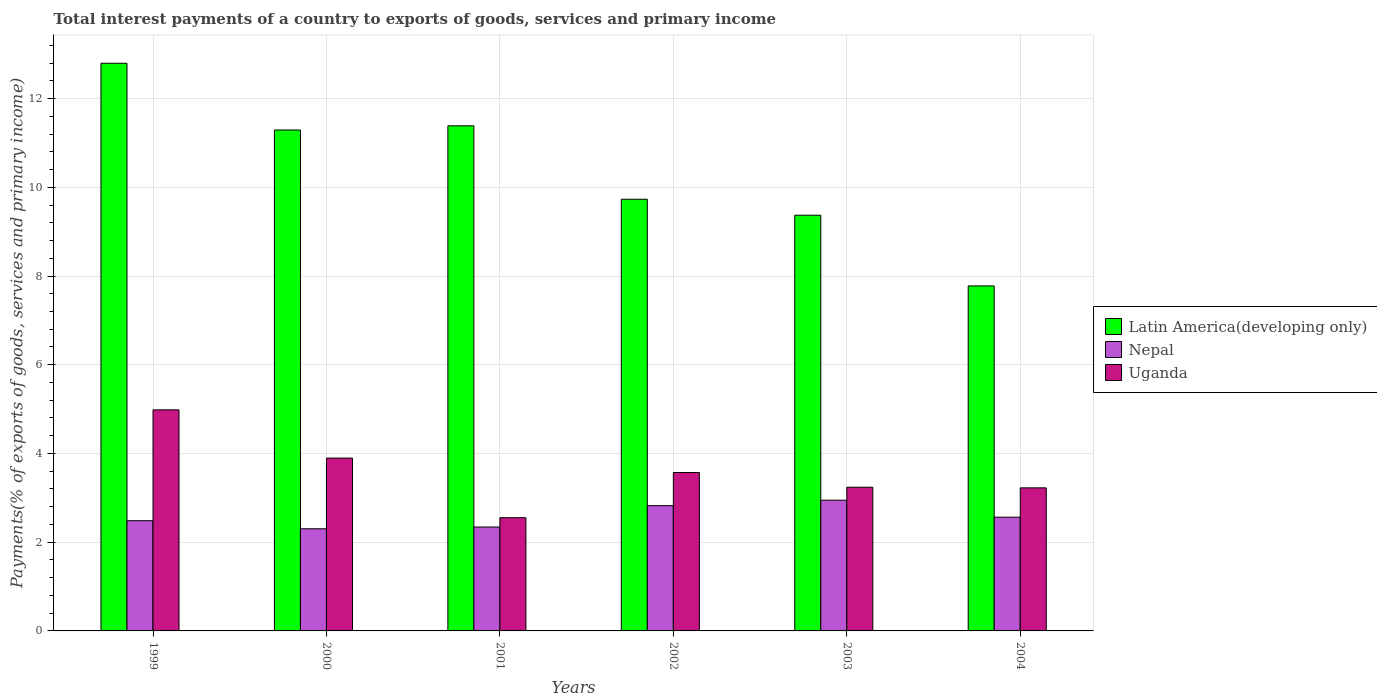How many groups of bars are there?
Your response must be concise. 6. Are the number of bars per tick equal to the number of legend labels?
Make the answer very short. Yes. How many bars are there on the 5th tick from the left?
Your answer should be compact. 3. What is the total interest payments in Latin America(developing only) in 1999?
Your answer should be very brief. 12.8. Across all years, what is the maximum total interest payments in Uganda?
Make the answer very short. 4.98. Across all years, what is the minimum total interest payments in Nepal?
Your answer should be compact. 2.3. In which year was the total interest payments in Nepal maximum?
Give a very brief answer. 2003. What is the total total interest payments in Uganda in the graph?
Offer a very short reply. 21.47. What is the difference between the total interest payments in Uganda in 1999 and that in 2000?
Provide a succinct answer. 1.09. What is the difference between the total interest payments in Nepal in 2000 and the total interest payments in Uganda in 2001?
Provide a short and direct response. -0.25. What is the average total interest payments in Latin America(developing only) per year?
Give a very brief answer. 10.39. In the year 2003, what is the difference between the total interest payments in Latin America(developing only) and total interest payments in Uganda?
Give a very brief answer. 6.13. In how many years, is the total interest payments in Uganda greater than 8.4 %?
Offer a terse response. 0. What is the ratio of the total interest payments in Latin America(developing only) in 1999 to that in 2003?
Make the answer very short. 1.37. Is the total interest payments in Latin America(developing only) in 2001 less than that in 2003?
Ensure brevity in your answer.  No. What is the difference between the highest and the second highest total interest payments in Latin America(developing only)?
Provide a succinct answer. 1.41. What is the difference between the highest and the lowest total interest payments in Nepal?
Your answer should be compact. 0.64. Is the sum of the total interest payments in Uganda in 2002 and 2004 greater than the maximum total interest payments in Nepal across all years?
Your answer should be very brief. Yes. What does the 3rd bar from the left in 2001 represents?
Provide a succinct answer. Uganda. What does the 1st bar from the right in 2002 represents?
Your answer should be compact. Uganda. Are all the bars in the graph horizontal?
Provide a succinct answer. No. What is the difference between two consecutive major ticks on the Y-axis?
Keep it short and to the point. 2. Does the graph contain any zero values?
Give a very brief answer. No. How many legend labels are there?
Your answer should be very brief. 3. What is the title of the graph?
Offer a very short reply. Total interest payments of a country to exports of goods, services and primary income. Does "Russian Federation" appear as one of the legend labels in the graph?
Offer a very short reply. No. What is the label or title of the Y-axis?
Provide a short and direct response. Payments(% of exports of goods, services and primary income). What is the Payments(% of exports of goods, services and primary income) of Latin America(developing only) in 1999?
Ensure brevity in your answer.  12.8. What is the Payments(% of exports of goods, services and primary income) in Nepal in 1999?
Provide a succinct answer. 2.48. What is the Payments(% of exports of goods, services and primary income) of Uganda in 1999?
Provide a succinct answer. 4.98. What is the Payments(% of exports of goods, services and primary income) in Latin America(developing only) in 2000?
Provide a succinct answer. 11.29. What is the Payments(% of exports of goods, services and primary income) of Nepal in 2000?
Give a very brief answer. 2.3. What is the Payments(% of exports of goods, services and primary income) of Uganda in 2000?
Offer a very short reply. 3.9. What is the Payments(% of exports of goods, services and primary income) of Latin America(developing only) in 2001?
Provide a succinct answer. 11.39. What is the Payments(% of exports of goods, services and primary income) in Nepal in 2001?
Provide a short and direct response. 2.34. What is the Payments(% of exports of goods, services and primary income) of Uganda in 2001?
Give a very brief answer. 2.55. What is the Payments(% of exports of goods, services and primary income) of Latin America(developing only) in 2002?
Keep it short and to the point. 9.73. What is the Payments(% of exports of goods, services and primary income) of Nepal in 2002?
Your answer should be compact. 2.82. What is the Payments(% of exports of goods, services and primary income) of Uganda in 2002?
Offer a very short reply. 3.57. What is the Payments(% of exports of goods, services and primary income) of Latin America(developing only) in 2003?
Offer a very short reply. 9.37. What is the Payments(% of exports of goods, services and primary income) of Nepal in 2003?
Provide a succinct answer. 2.95. What is the Payments(% of exports of goods, services and primary income) in Uganda in 2003?
Offer a terse response. 3.24. What is the Payments(% of exports of goods, services and primary income) of Latin America(developing only) in 2004?
Provide a short and direct response. 7.78. What is the Payments(% of exports of goods, services and primary income) of Nepal in 2004?
Offer a terse response. 2.56. What is the Payments(% of exports of goods, services and primary income) in Uganda in 2004?
Offer a very short reply. 3.22. Across all years, what is the maximum Payments(% of exports of goods, services and primary income) in Latin America(developing only)?
Your response must be concise. 12.8. Across all years, what is the maximum Payments(% of exports of goods, services and primary income) of Nepal?
Your answer should be compact. 2.95. Across all years, what is the maximum Payments(% of exports of goods, services and primary income) of Uganda?
Your answer should be very brief. 4.98. Across all years, what is the minimum Payments(% of exports of goods, services and primary income) of Latin America(developing only)?
Give a very brief answer. 7.78. Across all years, what is the minimum Payments(% of exports of goods, services and primary income) in Nepal?
Give a very brief answer. 2.3. Across all years, what is the minimum Payments(% of exports of goods, services and primary income) of Uganda?
Your response must be concise. 2.55. What is the total Payments(% of exports of goods, services and primary income) of Latin America(developing only) in the graph?
Offer a terse response. 62.35. What is the total Payments(% of exports of goods, services and primary income) in Nepal in the graph?
Your answer should be compact. 15.46. What is the total Payments(% of exports of goods, services and primary income) in Uganda in the graph?
Provide a succinct answer. 21.47. What is the difference between the Payments(% of exports of goods, services and primary income) of Latin America(developing only) in 1999 and that in 2000?
Your response must be concise. 1.5. What is the difference between the Payments(% of exports of goods, services and primary income) in Nepal in 1999 and that in 2000?
Ensure brevity in your answer.  0.18. What is the difference between the Payments(% of exports of goods, services and primary income) of Uganda in 1999 and that in 2000?
Your answer should be compact. 1.09. What is the difference between the Payments(% of exports of goods, services and primary income) in Latin America(developing only) in 1999 and that in 2001?
Your answer should be very brief. 1.41. What is the difference between the Payments(% of exports of goods, services and primary income) in Nepal in 1999 and that in 2001?
Ensure brevity in your answer.  0.14. What is the difference between the Payments(% of exports of goods, services and primary income) in Uganda in 1999 and that in 2001?
Provide a succinct answer. 2.43. What is the difference between the Payments(% of exports of goods, services and primary income) of Latin America(developing only) in 1999 and that in 2002?
Keep it short and to the point. 3.07. What is the difference between the Payments(% of exports of goods, services and primary income) of Nepal in 1999 and that in 2002?
Offer a terse response. -0.34. What is the difference between the Payments(% of exports of goods, services and primary income) in Uganda in 1999 and that in 2002?
Make the answer very short. 1.41. What is the difference between the Payments(% of exports of goods, services and primary income) in Latin America(developing only) in 1999 and that in 2003?
Your answer should be compact. 3.43. What is the difference between the Payments(% of exports of goods, services and primary income) of Nepal in 1999 and that in 2003?
Give a very brief answer. -0.46. What is the difference between the Payments(% of exports of goods, services and primary income) of Uganda in 1999 and that in 2003?
Make the answer very short. 1.74. What is the difference between the Payments(% of exports of goods, services and primary income) of Latin America(developing only) in 1999 and that in 2004?
Your response must be concise. 5.02. What is the difference between the Payments(% of exports of goods, services and primary income) of Nepal in 1999 and that in 2004?
Your answer should be compact. -0.08. What is the difference between the Payments(% of exports of goods, services and primary income) in Uganda in 1999 and that in 2004?
Provide a succinct answer. 1.76. What is the difference between the Payments(% of exports of goods, services and primary income) in Latin America(developing only) in 2000 and that in 2001?
Offer a very short reply. -0.09. What is the difference between the Payments(% of exports of goods, services and primary income) of Nepal in 2000 and that in 2001?
Offer a very short reply. -0.04. What is the difference between the Payments(% of exports of goods, services and primary income) of Uganda in 2000 and that in 2001?
Make the answer very short. 1.34. What is the difference between the Payments(% of exports of goods, services and primary income) of Latin America(developing only) in 2000 and that in 2002?
Make the answer very short. 1.56. What is the difference between the Payments(% of exports of goods, services and primary income) in Nepal in 2000 and that in 2002?
Offer a very short reply. -0.52. What is the difference between the Payments(% of exports of goods, services and primary income) in Uganda in 2000 and that in 2002?
Your response must be concise. 0.33. What is the difference between the Payments(% of exports of goods, services and primary income) of Latin America(developing only) in 2000 and that in 2003?
Make the answer very short. 1.92. What is the difference between the Payments(% of exports of goods, services and primary income) of Nepal in 2000 and that in 2003?
Offer a very short reply. -0.64. What is the difference between the Payments(% of exports of goods, services and primary income) in Uganda in 2000 and that in 2003?
Keep it short and to the point. 0.66. What is the difference between the Payments(% of exports of goods, services and primary income) in Latin America(developing only) in 2000 and that in 2004?
Offer a very short reply. 3.51. What is the difference between the Payments(% of exports of goods, services and primary income) in Nepal in 2000 and that in 2004?
Offer a very short reply. -0.26. What is the difference between the Payments(% of exports of goods, services and primary income) in Uganda in 2000 and that in 2004?
Your answer should be very brief. 0.67. What is the difference between the Payments(% of exports of goods, services and primary income) of Latin America(developing only) in 2001 and that in 2002?
Offer a very short reply. 1.66. What is the difference between the Payments(% of exports of goods, services and primary income) of Nepal in 2001 and that in 2002?
Give a very brief answer. -0.48. What is the difference between the Payments(% of exports of goods, services and primary income) of Uganda in 2001 and that in 2002?
Your answer should be compact. -1.02. What is the difference between the Payments(% of exports of goods, services and primary income) in Latin America(developing only) in 2001 and that in 2003?
Your response must be concise. 2.02. What is the difference between the Payments(% of exports of goods, services and primary income) of Nepal in 2001 and that in 2003?
Offer a terse response. -0.6. What is the difference between the Payments(% of exports of goods, services and primary income) of Uganda in 2001 and that in 2003?
Your answer should be compact. -0.69. What is the difference between the Payments(% of exports of goods, services and primary income) in Latin America(developing only) in 2001 and that in 2004?
Keep it short and to the point. 3.61. What is the difference between the Payments(% of exports of goods, services and primary income) in Nepal in 2001 and that in 2004?
Give a very brief answer. -0.22. What is the difference between the Payments(% of exports of goods, services and primary income) of Uganda in 2001 and that in 2004?
Offer a terse response. -0.67. What is the difference between the Payments(% of exports of goods, services and primary income) in Latin America(developing only) in 2002 and that in 2003?
Offer a terse response. 0.36. What is the difference between the Payments(% of exports of goods, services and primary income) in Nepal in 2002 and that in 2003?
Ensure brevity in your answer.  -0.12. What is the difference between the Payments(% of exports of goods, services and primary income) of Uganda in 2002 and that in 2003?
Your response must be concise. 0.33. What is the difference between the Payments(% of exports of goods, services and primary income) of Latin America(developing only) in 2002 and that in 2004?
Your answer should be compact. 1.95. What is the difference between the Payments(% of exports of goods, services and primary income) in Nepal in 2002 and that in 2004?
Make the answer very short. 0.26. What is the difference between the Payments(% of exports of goods, services and primary income) of Uganda in 2002 and that in 2004?
Ensure brevity in your answer.  0.35. What is the difference between the Payments(% of exports of goods, services and primary income) in Latin America(developing only) in 2003 and that in 2004?
Make the answer very short. 1.59. What is the difference between the Payments(% of exports of goods, services and primary income) in Nepal in 2003 and that in 2004?
Offer a terse response. 0.38. What is the difference between the Payments(% of exports of goods, services and primary income) of Uganda in 2003 and that in 2004?
Your response must be concise. 0.01. What is the difference between the Payments(% of exports of goods, services and primary income) of Latin America(developing only) in 1999 and the Payments(% of exports of goods, services and primary income) of Nepal in 2000?
Make the answer very short. 10.49. What is the difference between the Payments(% of exports of goods, services and primary income) in Latin America(developing only) in 1999 and the Payments(% of exports of goods, services and primary income) in Uganda in 2000?
Provide a succinct answer. 8.9. What is the difference between the Payments(% of exports of goods, services and primary income) of Nepal in 1999 and the Payments(% of exports of goods, services and primary income) of Uganda in 2000?
Keep it short and to the point. -1.41. What is the difference between the Payments(% of exports of goods, services and primary income) of Latin America(developing only) in 1999 and the Payments(% of exports of goods, services and primary income) of Nepal in 2001?
Give a very brief answer. 10.45. What is the difference between the Payments(% of exports of goods, services and primary income) in Latin America(developing only) in 1999 and the Payments(% of exports of goods, services and primary income) in Uganda in 2001?
Your answer should be compact. 10.24. What is the difference between the Payments(% of exports of goods, services and primary income) of Nepal in 1999 and the Payments(% of exports of goods, services and primary income) of Uganda in 2001?
Offer a very short reply. -0.07. What is the difference between the Payments(% of exports of goods, services and primary income) in Latin America(developing only) in 1999 and the Payments(% of exports of goods, services and primary income) in Nepal in 2002?
Make the answer very short. 9.97. What is the difference between the Payments(% of exports of goods, services and primary income) of Latin America(developing only) in 1999 and the Payments(% of exports of goods, services and primary income) of Uganda in 2002?
Give a very brief answer. 9.22. What is the difference between the Payments(% of exports of goods, services and primary income) in Nepal in 1999 and the Payments(% of exports of goods, services and primary income) in Uganda in 2002?
Ensure brevity in your answer.  -1.09. What is the difference between the Payments(% of exports of goods, services and primary income) in Latin America(developing only) in 1999 and the Payments(% of exports of goods, services and primary income) in Nepal in 2003?
Provide a succinct answer. 9.85. What is the difference between the Payments(% of exports of goods, services and primary income) in Latin America(developing only) in 1999 and the Payments(% of exports of goods, services and primary income) in Uganda in 2003?
Provide a short and direct response. 9.56. What is the difference between the Payments(% of exports of goods, services and primary income) of Nepal in 1999 and the Payments(% of exports of goods, services and primary income) of Uganda in 2003?
Ensure brevity in your answer.  -0.75. What is the difference between the Payments(% of exports of goods, services and primary income) of Latin America(developing only) in 1999 and the Payments(% of exports of goods, services and primary income) of Nepal in 2004?
Ensure brevity in your answer.  10.23. What is the difference between the Payments(% of exports of goods, services and primary income) of Latin America(developing only) in 1999 and the Payments(% of exports of goods, services and primary income) of Uganda in 2004?
Your response must be concise. 9.57. What is the difference between the Payments(% of exports of goods, services and primary income) of Nepal in 1999 and the Payments(% of exports of goods, services and primary income) of Uganda in 2004?
Make the answer very short. -0.74. What is the difference between the Payments(% of exports of goods, services and primary income) in Latin America(developing only) in 2000 and the Payments(% of exports of goods, services and primary income) in Nepal in 2001?
Ensure brevity in your answer.  8.95. What is the difference between the Payments(% of exports of goods, services and primary income) in Latin America(developing only) in 2000 and the Payments(% of exports of goods, services and primary income) in Uganda in 2001?
Your answer should be very brief. 8.74. What is the difference between the Payments(% of exports of goods, services and primary income) of Nepal in 2000 and the Payments(% of exports of goods, services and primary income) of Uganda in 2001?
Provide a short and direct response. -0.25. What is the difference between the Payments(% of exports of goods, services and primary income) in Latin America(developing only) in 2000 and the Payments(% of exports of goods, services and primary income) in Nepal in 2002?
Offer a very short reply. 8.47. What is the difference between the Payments(% of exports of goods, services and primary income) of Latin America(developing only) in 2000 and the Payments(% of exports of goods, services and primary income) of Uganda in 2002?
Your answer should be very brief. 7.72. What is the difference between the Payments(% of exports of goods, services and primary income) in Nepal in 2000 and the Payments(% of exports of goods, services and primary income) in Uganda in 2002?
Provide a short and direct response. -1.27. What is the difference between the Payments(% of exports of goods, services and primary income) of Latin America(developing only) in 2000 and the Payments(% of exports of goods, services and primary income) of Nepal in 2003?
Keep it short and to the point. 8.34. What is the difference between the Payments(% of exports of goods, services and primary income) of Latin America(developing only) in 2000 and the Payments(% of exports of goods, services and primary income) of Uganda in 2003?
Offer a terse response. 8.05. What is the difference between the Payments(% of exports of goods, services and primary income) in Nepal in 2000 and the Payments(% of exports of goods, services and primary income) in Uganda in 2003?
Your answer should be very brief. -0.94. What is the difference between the Payments(% of exports of goods, services and primary income) of Latin America(developing only) in 2000 and the Payments(% of exports of goods, services and primary income) of Nepal in 2004?
Offer a very short reply. 8.73. What is the difference between the Payments(% of exports of goods, services and primary income) in Latin America(developing only) in 2000 and the Payments(% of exports of goods, services and primary income) in Uganda in 2004?
Make the answer very short. 8.07. What is the difference between the Payments(% of exports of goods, services and primary income) in Nepal in 2000 and the Payments(% of exports of goods, services and primary income) in Uganda in 2004?
Provide a short and direct response. -0.92. What is the difference between the Payments(% of exports of goods, services and primary income) of Latin America(developing only) in 2001 and the Payments(% of exports of goods, services and primary income) of Nepal in 2002?
Your response must be concise. 8.56. What is the difference between the Payments(% of exports of goods, services and primary income) of Latin America(developing only) in 2001 and the Payments(% of exports of goods, services and primary income) of Uganda in 2002?
Ensure brevity in your answer.  7.81. What is the difference between the Payments(% of exports of goods, services and primary income) of Nepal in 2001 and the Payments(% of exports of goods, services and primary income) of Uganda in 2002?
Provide a short and direct response. -1.23. What is the difference between the Payments(% of exports of goods, services and primary income) in Latin America(developing only) in 2001 and the Payments(% of exports of goods, services and primary income) in Nepal in 2003?
Ensure brevity in your answer.  8.44. What is the difference between the Payments(% of exports of goods, services and primary income) in Latin America(developing only) in 2001 and the Payments(% of exports of goods, services and primary income) in Uganda in 2003?
Make the answer very short. 8.15. What is the difference between the Payments(% of exports of goods, services and primary income) in Nepal in 2001 and the Payments(% of exports of goods, services and primary income) in Uganda in 2003?
Your answer should be compact. -0.9. What is the difference between the Payments(% of exports of goods, services and primary income) of Latin America(developing only) in 2001 and the Payments(% of exports of goods, services and primary income) of Nepal in 2004?
Ensure brevity in your answer.  8.82. What is the difference between the Payments(% of exports of goods, services and primary income) of Latin America(developing only) in 2001 and the Payments(% of exports of goods, services and primary income) of Uganda in 2004?
Ensure brevity in your answer.  8.16. What is the difference between the Payments(% of exports of goods, services and primary income) in Nepal in 2001 and the Payments(% of exports of goods, services and primary income) in Uganda in 2004?
Your response must be concise. -0.88. What is the difference between the Payments(% of exports of goods, services and primary income) of Latin America(developing only) in 2002 and the Payments(% of exports of goods, services and primary income) of Nepal in 2003?
Ensure brevity in your answer.  6.78. What is the difference between the Payments(% of exports of goods, services and primary income) of Latin America(developing only) in 2002 and the Payments(% of exports of goods, services and primary income) of Uganda in 2003?
Provide a succinct answer. 6.49. What is the difference between the Payments(% of exports of goods, services and primary income) of Nepal in 2002 and the Payments(% of exports of goods, services and primary income) of Uganda in 2003?
Keep it short and to the point. -0.42. What is the difference between the Payments(% of exports of goods, services and primary income) in Latin America(developing only) in 2002 and the Payments(% of exports of goods, services and primary income) in Nepal in 2004?
Provide a short and direct response. 7.17. What is the difference between the Payments(% of exports of goods, services and primary income) of Latin America(developing only) in 2002 and the Payments(% of exports of goods, services and primary income) of Uganda in 2004?
Provide a succinct answer. 6.51. What is the difference between the Payments(% of exports of goods, services and primary income) in Nepal in 2002 and the Payments(% of exports of goods, services and primary income) in Uganda in 2004?
Provide a short and direct response. -0.4. What is the difference between the Payments(% of exports of goods, services and primary income) of Latin America(developing only) in 2003 and the Payments(% of exports of goods, services and primary income) of Nepal in 2004?
Offer a very short reply. 6.81. What is the difference between the Payments(% of exports of goods, services and primary income) of Latin America(developing only) in 2003 and the Payments(% of exports of goods, services and primary income) of Uganda in 2004?
Offer a terse response. 6.14. What is the difference between the Payments(% of exports of goods, services and primary income) in Nepal in 2003 and the Payments(% of exports of goods, services and primary income) in Uganda in 2004?
Offer a very short reply. -0.28. What is the average Payments(% of exports of goods, services and primary income) of Latin America(developing only) per year?
Provide a succinct answer. 10.39. What is the average Payments(% of exports of goods, services and primary income) of Nepal per year?
Make the answer very short. 2.58. What is the average Payments(% of exports of goods, services and primary income) of Uganda per year?
Provide a succinct answer. 3.58. In the year 1999, what is the difference between the Payments(% of exports of goods, services and primary income) of Latin America(developing only) and Payments(% of exports of goods, services and primary income) of Nepal?
Make the answer very short. 10.31. In the year 1999, what is the difference between the Payments(% of exports of goods, services and primary income) in Latin America(developing only) and Payments(% of exports of goods, services and primary income) in Uganda?
Your answer should be very brief. 7.81. In the year 1999, what is the difference between the Payments(% of exports of goods, services and primary income) of Nepal and Payments(% of exports of goods, services and primary income) of Uganda?
Your answer should be compact. -2.5. In the year 2000, what is the difference between the Payments(% of exports of goods, services and primary income) in Latin America(developing only) and Payments(% of exports of goods, services and primary income) in Nepal?
Your answer should be compact. 8.99. In the year 2000, what is the difference between the Payments(% of exports of goods, services and primary income) in Latin America(developing only) and Payments(% of exports of goods, services and primary income) in Uganda?
Offer a very short reply. 7.4. In the year 2000, what is the difference between the Payments(% of exports of goods, services and primary income) in Nepal and Payments(% of exports of goods, services and primary income) in Uganda?
Your response must be concise. -1.59. In the year 2001, what is the difference between the Payments(% of exports of goods, services and primary income) in Latin America(developing only) and Payments(% of exports of goods, services and primary income) in Nepal?
Give a very brief answer. 9.04. In the year 2001, what is the difference between the Payments(% of exports of goods, services and primary income) in Latin America(developing only) and Payments(% of exports of goods, services and primary income) in Uganda?
Your response must be concise. 8.83. In the year 2001, what is the difference between the Payments(% of exports of goods, services and primary income) in Nepal and Payments(% of exports of goods, services and primary income) in Uganda?
Your answer should be compact. -0.21. In the year 2002, what is the difference between the Payments(% of exports of goods, services and primary income) in Latin America(developing only) and Payments(% of exports of goods, services and primary income) in Nepal?
Offer a very short reply. 6.91. In the year 2002, what is the difference between the Payments(% of exports of goods, services and primary income) in Latin America(developing only) and Payments(% of exports of goods, services and primary income) in Uganda?
Give a very brief answer. 6.16. In the year 2002, what is the difference between the Payments(% of exports of goods, services and primary income) in Nepal and Payments(% of exports of goods, services and primary income) in Uganda?
Your response must be concise. -0.75. In the year 2003, what is the difference between the Payments(% of exports of goods, services and primary income) of Latin America(developing only) and Payments(% of exports of goods, services and primary income) of Nepal?
Your response must be concise. 6.42. In the year 2003, what is the difference between the Payments(% of exports of goods, services and primary income) in Latin America(developing only) and Payments(% of exports of goods, services and primary income) in Uganda?
Offer a terse response. 6.13. In the year 2003, what is the difference between the Payments(% of exports of goods, services and primary income) in Nepal and Payments(% of exports of goods, services and primary income) in Uganda?
Make the answer very short. -0.29. In the year 2004, what is the difference between the Payments(% of exports of goods, services and primary income) in Latin America(developing only) and Payments(% of exports of goods, services and primary income) in Nepal?
Your answer should be very brief. 5.21. In the year 2004, what is the difference between the Payments(% of exports of goods, services and primary income) in Latin America(developing only) and Payments(% of exports of goods, services and primary income) in Uganda?
Provide a short and direct response. 4.55. In the year 2004, what is the difference between the Payments(% of exports of goods, services and primary income) in Nepal and Payments(% of exports of goods, services and primary income) in Uganda?
Your answer should be very brief. -0.66. What is the ratio of the Payments(% of exports of goods, services and primary income) in Latin America(developing only) in 1999 to that in 2000?
Ensure brevity in your answer.  1.13. What is the ratio of the Payments(% of exports of goods, services and primary income) in Nepal in 1999 to that in 2000?
Provide a short and direct response. 1.08. What is the ratio of the Payments(% of exports of goods, services and primary income) in Uganda in 1999 to that in 2000?
Keep it short and to the point. 1.28. What is the ratio of the Payments(% of exports of goods, services and primary income) in Latin America(developing only) in 1999 to that in 2001?
Offer a very short reply. 1.12. What is the ratio of the Payments(% of exports of goods, services and primary income) in Nepal in 1999 to that in 2001?
Make the answer very short. 1.06. What is the ratio of the Payments(% of exports of goods, services and primary income) in Uganda in 1999 to that in 2001?
Ensure brevity in your answer.  1.95. What is the ratio of the Payments(% of exports of goods, services and primary income) of Latin America(developing only) in 1999 to that in 2002?
Your answer should be very brief. 1.31. What is the ratio of the Payments(% of exports of goods, services and primary income) of Nepal in 1999 to that in 2002?
Offer a terse response. 0.88. What is the ratio of the Payments(% of exports of goods, services and primary income) of Uganda in 1999 to that in 2002?
Keep it short and to the point. 1.4. What is the ratio of the Payments(% of exports of goods, services and primary income) in Latin America(developing only) in 1999 to that in 2003?
Ensure brevity in your answer.  1.37. What is the ratio of the Payments(% of exports of goods, services and primary income) in Nepal in 1999 to that in 2003?
Keep it short and to the point. 0.84. What is the ratio of the Payments(% of exports of goods, services and primary income) of Uganda in 1999 to that in 2003?
Ensure brevity in your answer.  1.54. What is the ratio of the Payments(% of exports of goods, services and primary income) of Latin America(developing only) in 1999 to that in 2004?
Offer a very short reply. 1.65. What is the ratio of the Payments(% of exports of goods, services and primary income) of Nepal in 1999 to that in 2004?
Make the answer very short. 0.97. What is the ratio of the Payments(% of exports of goods, services and primary income) of Uganda in 1999 to that in 2004?
Provide a short and direct response. 1.55. What is the ratio of the Payments(% of exports of goods, services and primary income) of Latin America(developing only) in 2000 to that in 2001?
Provide a succinct answer. 0.99. What is the ratio of the Payments(% of exports of goods, services and primary income) in Nepal in 2000 to that in 2001?
Provide a short and direct response. 0.98. What is the ratio of the Payments(% of exports of goods, services and primary income) of Uganda in 2000 to that in 2001?
Ensure brevity in your answer.  1.53. What is the ratio of the Payments(% of exports of goods, services and primary income) in Latin America(developing only) in 2000 to that in 2002?
Offer a terse response. 1.16. What is the ratio of the Payments(% of exports of goods, services and primary income) of Nepal in 2000 to that in 2002?
Make the answer very short. 0.82. What is the ratio of the Payments(% of exports of goods, services and primary income) of Uganda in 2000 to that in 2002?
Your answer should be very brief. 1.09. What is the ratio of the Payments(% of exports of goods, services and primary income) in Latin America(developing only) in 2000 to that in 2003?
Your answer should be compact. 1.21. What is the ratio of the Payments(% of exports of goods, services and primary income) of Nepal in 2000 to that in 2003?
Give a very brief answer. 0.78. What is the ratio of the Payments(% of exports of goods, services and primary income) in Uganda in 2000 to that in 2003?
Ensure brevity in your answer.  1.2. What is the ratio of the Payments(% of exports of goods, services and primary income) in Latin America(developing only) in 2000 to that in 2004?
Make the answer very short. 1.45. What is the ratio of the Payments(% of exports of goods, services and primary income) of Nepal in 2000 to that in 2004?
Your answer should be compact. 0.9. What is the ratio of the Payments(% of exports of goods, services and primary income) of Uganda in 2000 to that in 2004?
Make the answer very short. 1.21. What is the ratio of the Payments(% of exports of goods, services and primary income) of Latin America(developing only) in 2001 to that in 2002?
Your response must be concise. 1.17. What is the ratio of the Payments(% of exports of goods, services and primary income) of Nepal in 2001 to that in 2002?
Keep it short and to the point. 0.83. What is the ratio of the Payments(% of exports of goods, services and primary income) of Uganda in 2001 to that in 2002?
Provide a short and direct response. 0.71. What is the ratio of the Payments(% of exports of goods, services and primary income) in Latin America(developing only) in 2001 to that in 2003?
Provide a short and direct response. 1.22. What is the ratio of the Payments(% of exports of goods, services and primary income) in Nepal in 2001 to that in 2003?
Your response must be concise. 0.79. What is the ratio of the Payments(% of exports of goods, services and primary income) in Uganda in 2001 to that in 2003?
Give a very brief answer. 0.79. What is the ratio of the Payments(% of exports of goods, services and primary income) in Latin America(developing only) in 2001 to that in 2004?
Provide a succinct answer. 1.46. What is the ratio of the Payments(% of exports of goods, services and primary income) in Nepal in 2001 to that in 2004?
Give a very brief answer. 0.91. What is the ratio of the Payments(% of exports of goods, services and primary income) in Uganda in 2001 to that in 2004?
Give a very brief answer. 0.79. What is the ratio of the Payments(% of exports of goods, services and primary income) in Nepal in 2002 to that in 2003?
Offer a terse response. 0.96. What is the ratio of the Payments(% of exports of goods, services and primary income) in Uganda in 2002 to that in 2003?
Ensure brevity in your answer.  1.1. What is the ratio of the Payments(% of exports of goods, services and primary income) in Latin America(developing only) in 2002 to that in 2004?
Ensure brevity in your answer.  1.25. What is the ratio of the Payments(% of exports of goods, services and primary income) of Nepal in 2002 to that in 2004?
Provide a succinct answer. 1.1. What is the ratio of the Payments(% of exports of goods, services and primary income) of Uganda in 2002 to that in 2004?
Give a very brief answer. 1.11. What is the ratio of the Payments(% of exports of goods, services and primary income) of Latin America(developing only) in 2003 to that in 2004?
Give a very brief answer. 1.2. What is the ratio of the Payments(% of exports of goods, services and primary income) in Nepal in 2003 to that in 2004?
Keep it short and to the point. 1.15. What is the ratio of the Payments(% of exports of goods, services and primary income) in Uganda in 2003 to that in 2004?
Offer a terse response. 1. What is the difference between the highest and the second highest Payments(% of exports of goods, services and primary income) in Latin America(developing only)?
Give a very brief answer. 1.41. What is the difference between the highest and the second highest Payments(% of exports of goods, services and primary income) of Nepal?
Offer a very short reply. 0.12. What is the difference between the highest and the second highest Payments(% of exports of goods, services and primary income) of Uganda?
Offer a very short reply. 1.09. What is the difference between the highest and the lowest Payments(% of exports of goods, services and primary income) in Latin America(developing only)?
Keep it short and to the point. 5.02. What is the difference between the highest and the lowest Payments(% of exports of goods, services and primary income) of Nepal?
Your answer should be very brief. 0.64. What is the difference between the highest and the lowest Payments(% of exports of goods, services and primary income) of Uganda?
Provide a short and direct response. 2.43. 